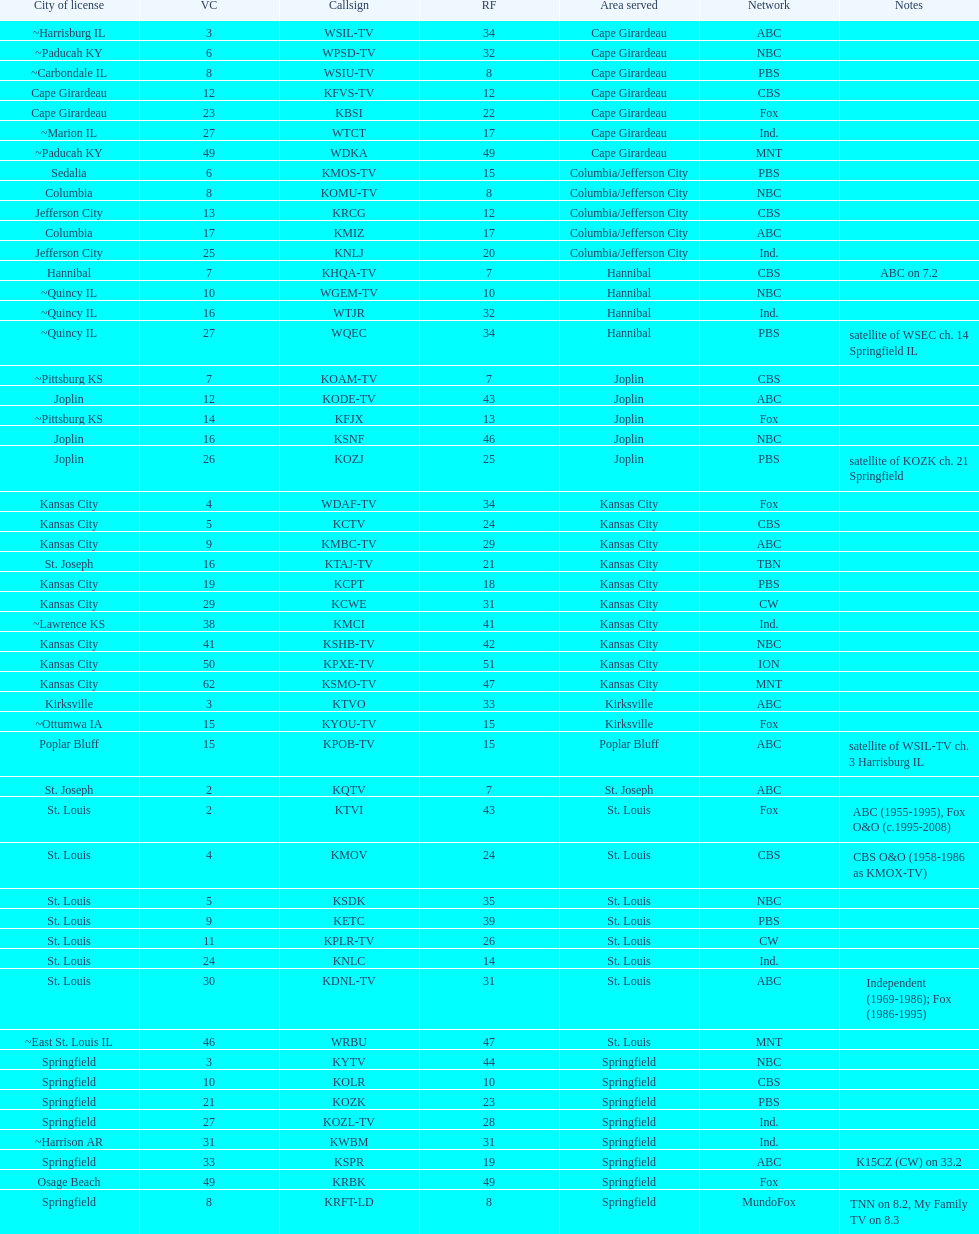What is the total number of stations serving the the cape girardeau area? 7. 